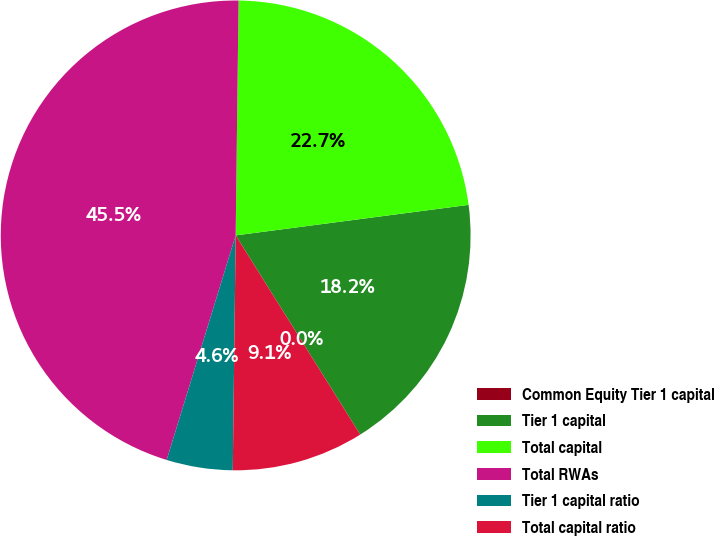Convert chart. <chart><loc_0><loc_0><loc_500><loc_500><pie_chart><fcel>Common Equity Tier 1 capital<fcel>Tier 1 capital<fcel>Total capital<fcel>Total RWAs<fcel>Tier 1 capital ratio<fcel>Total capital ratio<nl><fcel>0.0%<fcel>18.18%<fcel>22.73%<fcel>45.45%<fcel>4.55%<fcel>9.09%<nl></chart> 